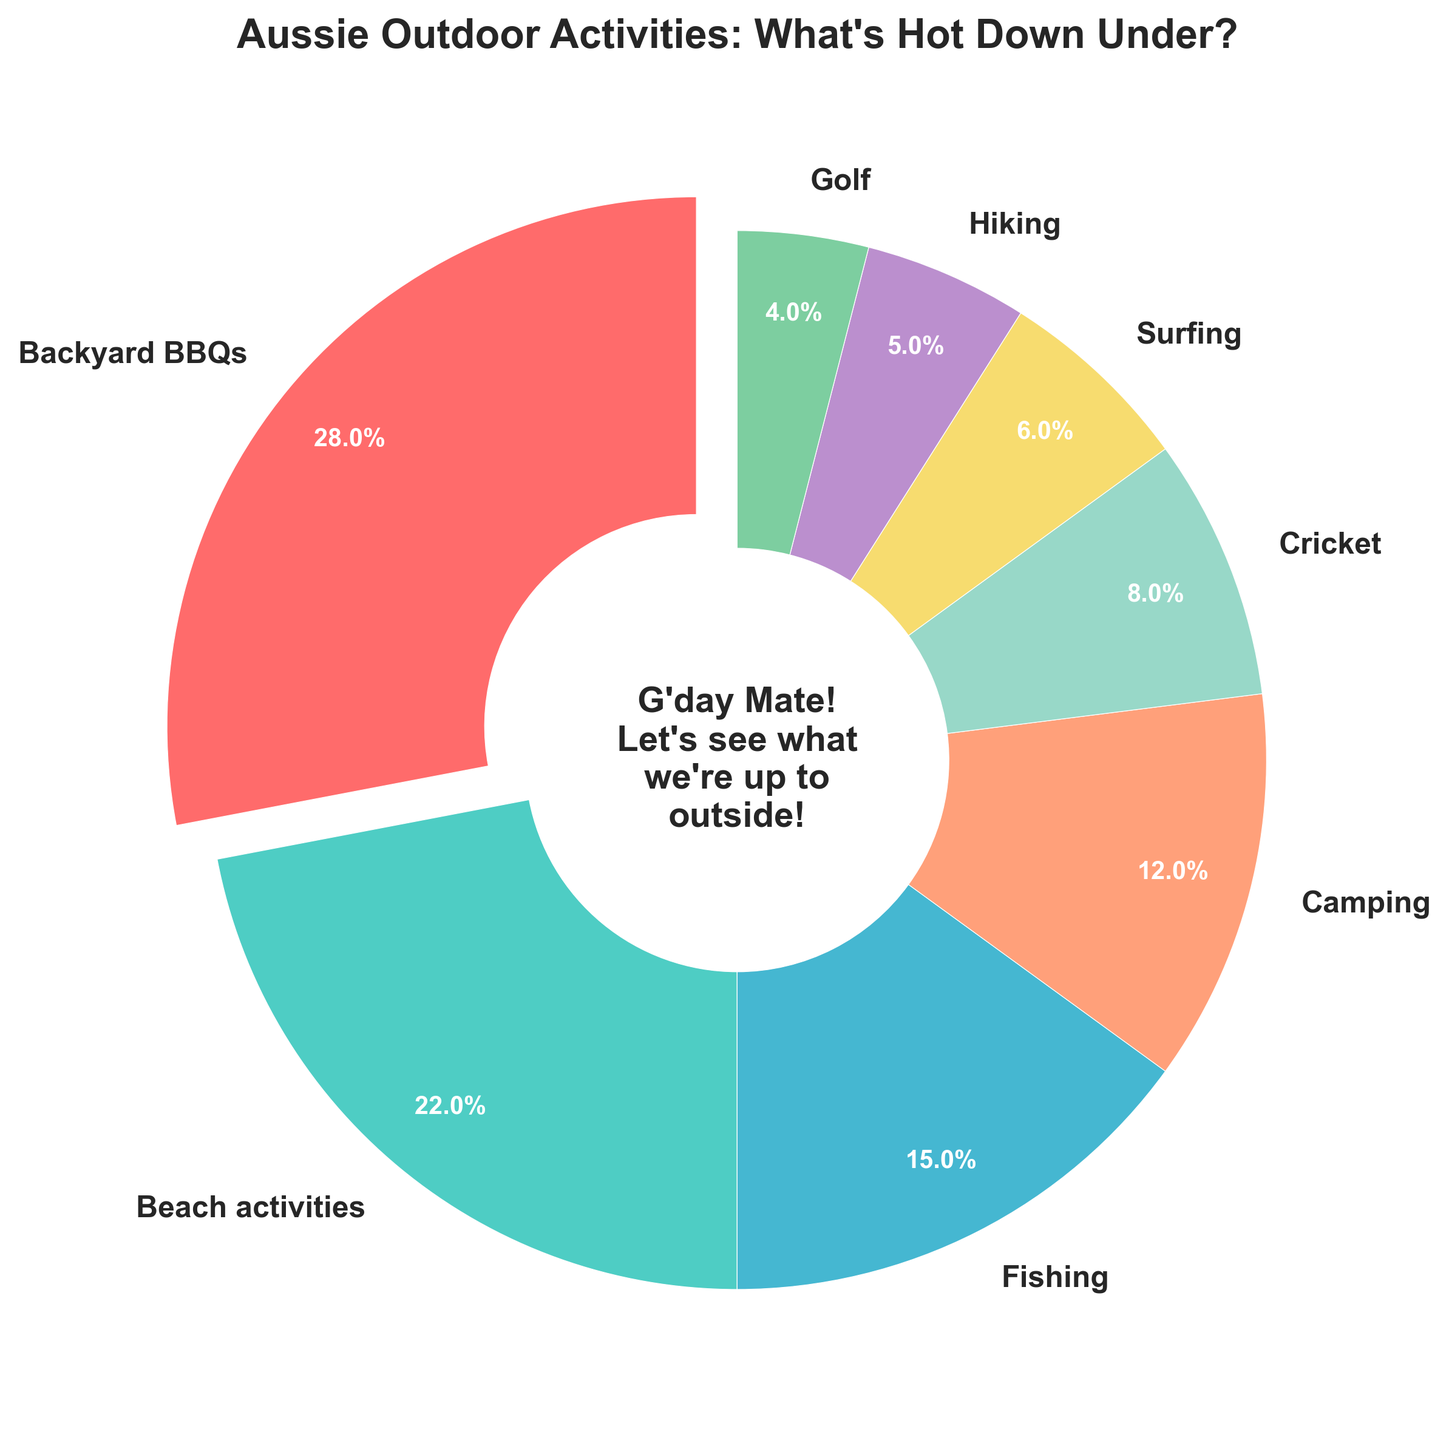Which outdoor activity has the highest participation rate? By looking at the pie chart, the largest wedge represents Backyard BBQs. The wedge is slightly pulled out from the rest, indicating it has the highest participation rate.
Answer: Backyard BBQs How much higher is the participation rate of Beach activities compared to Hiking? From the pie chart, Beach activities have a participation rate of 22% and Hiking has 5%. The difference can be calculated as 22% - 5% = 17%.
Answer: 17% What is the combined participation rate for Fishing and Golf? By looking at the pie chart, Fishing has a participation rate of 15% and Golf has 4%. Adding these two gives 15% + 4% = 19%.
Answer: 19% Which activity has a lower participation rate, Cricket or Surfing? The pie chart shows Cricket with 8% and Surfing with 6%. 6% is less than 8%, so Surfing has the lower participation rate.
Answer: Surfing How does the participation rate for Camping compare to Cricket? According to the pie chart, Camping has a participation rate of 12% while Cricket has 8%. 12% is greater than 8%.
Answer: Camping is higher What percentage of Australians participate in Beach activities, Fishing, and Surfing combined? From the pie chart: Beach activities = 22%, Fishing = 15%, Surfing = 6%. Adding them: 22% + 15% + 6% = 43%.
Answer: 43% Are there more participants in Surfing or Golf? The pie chart shows Surfing has a participation rate of 6% and Golf has 4%. 6% is more than 4%, so Surfing has more participants.
Answer: Surfing Which color represents Golf in the pie chart? From the pie chart, the wedge for Golf is colored green.
Answer: Green 